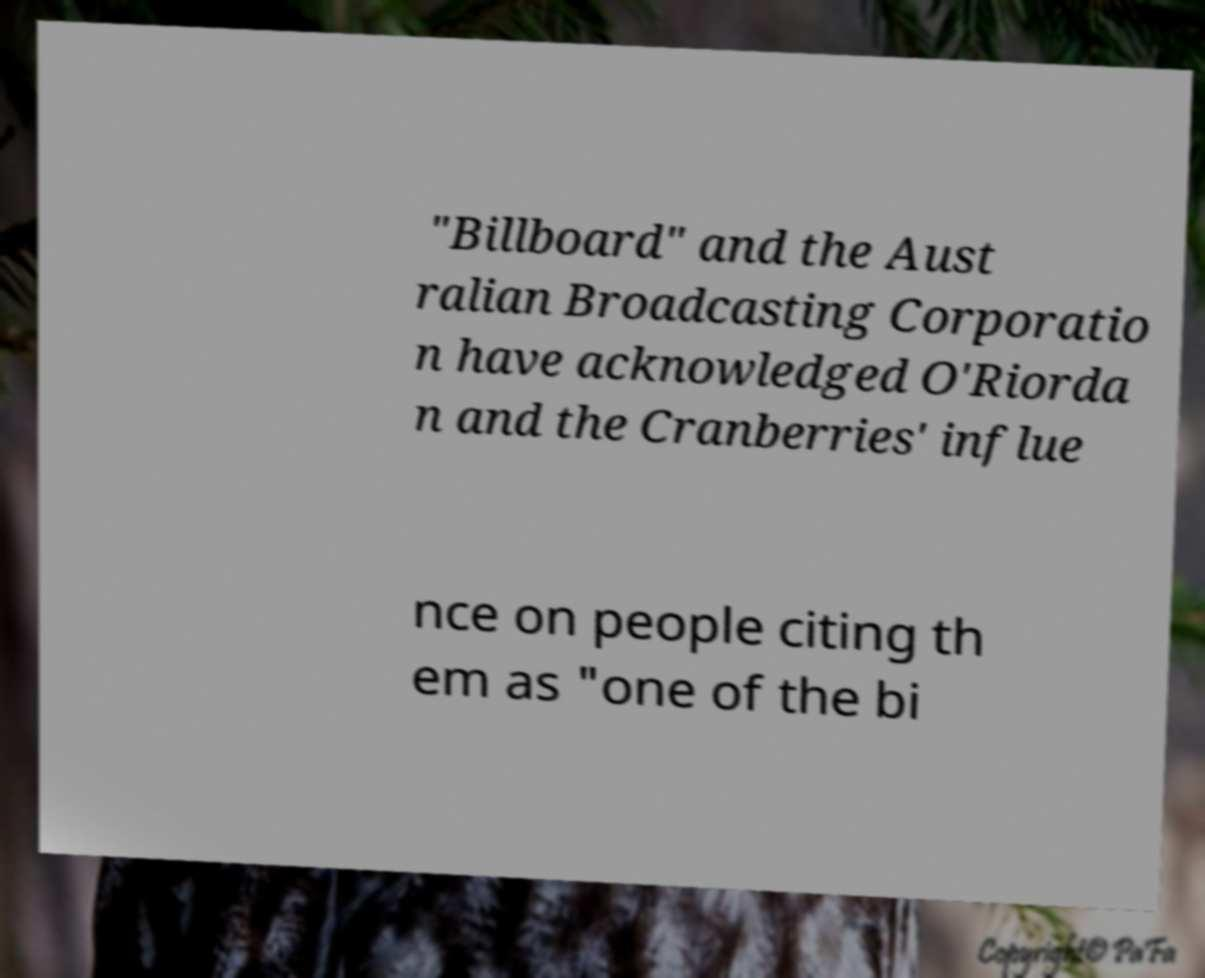Can you read and provide the text displayed in the image?This photo seems to have some interesting text. Can you extract and type it out for me? "Billboard" and the Aust ralian Broadcasting Corporatio n have acknowledged O'Riorda n and the Cranberries' influe nce on people citing th em as "one of the bi 